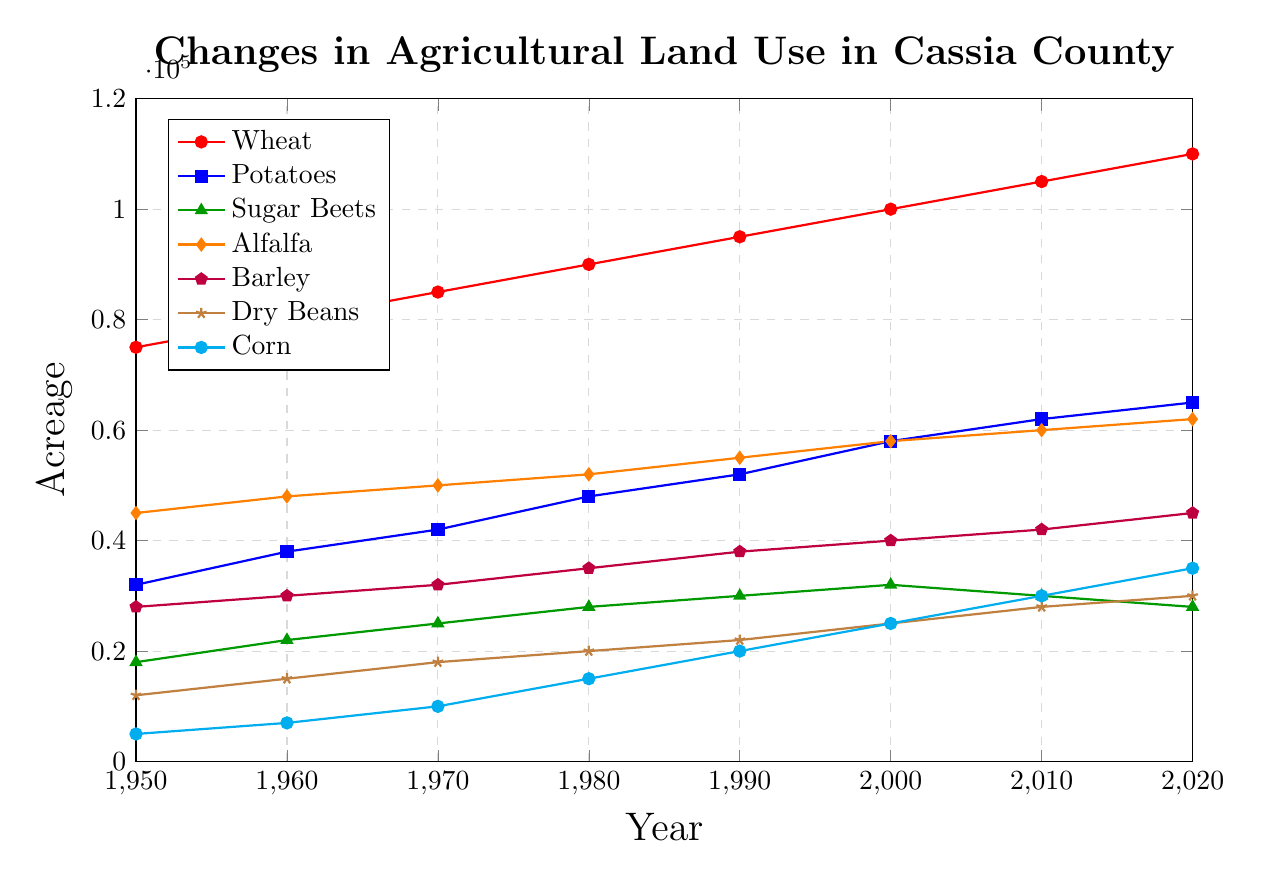Which crop had the highest acreage in 2020? From the figure, we see that the line representing Wheat has the highest point among all lines in 2020.
Answer: Wheat How many times did the acreage for Potatoes change direction (increase or decrease) from 1950 to 2020? The line for Potatoes shows a steady increase from 1950 to 2020 without any decrease.
Answer: 0 Which crop showed the steepest increase in acreage from 1950 to 2020? Visually, the line for Corn shows the steepest gradient from 1950 to 2020, culminating in the largest increase.
Answer: Corn What is the difference in acreage between Wheat and Barley in 2000? The Wheat acreage in 2000 is 100,000 and Barley is 40,000. Subtracting the two gives 100,000 - 40,000 = 60,000.
Answer: 60,000 Which crops had the same acreage in any given year? According to the figure, Alfalfa and Barley both have 60,000 acres in 2010.
Answer: Alfalfa and Barley Visualizing the lines, which crop shows a decrease in acreage between 2000 and 2010? The line for Sugar Beets decreases from 32,000 in 2000 to 30,000 in 2010.
Answer: Sugar Beets From the trend lines, which year did Dry Beans surpass 20,000 acres and sustain an increase? Dry Beans surpassed 20,000 acres in 1990 and continued to increase thereafter.
Answer: 1990 Averaging the acreage for Wheat from 1950 to 2020, what do we get? Summing the acreage values for Wheat from 1950 (75,000), 1960 (80,000), 1970 (85,000), 1980 (90,000), 1990 (95,000), 2000 (100,000), 2010 (105,000), and 2020 (110,000) gives 75,000 + 80,000 + 85,000 + 90,000 + 95,000 + 100,000 + 105,000 + 110,000 = 740,000. Dividing by 8 (number of years), the average is 740,000 / 8 = 92,500.
Answer: 92,500 In which decade did Alfalfa reach 50,000 acres for the first time? The line for Alfalfa reaches 50,000 acres for the first time in 1970.
Answer: 1970 